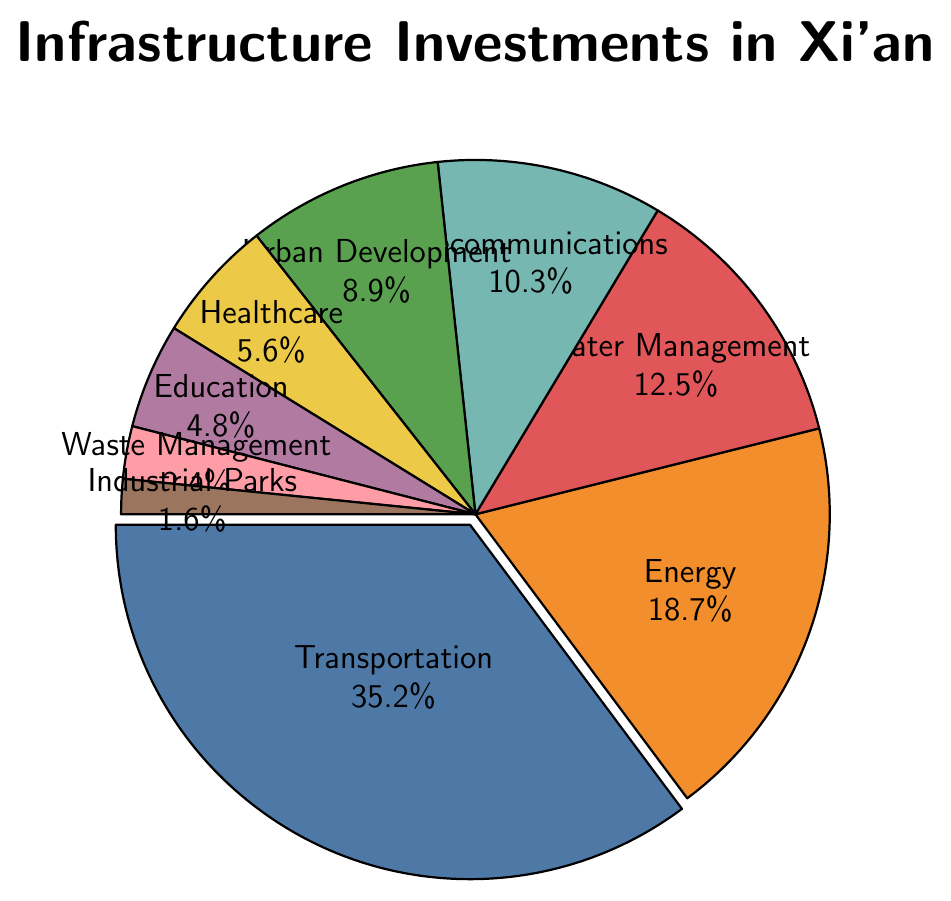Which sector has the highest investment percentage? The chart shows different sectors and their corresponding investment percentages. Among them, "Transportation" has the largest slice.
Answer: Transportation How much more is invested in Energy compared to Education Facilities? Energy investment is 18.7%, and Education Facilities is 4.8%. Subtract the two percentages to find the difference: 18.7% - 4.8% = 13.9%.
Answer: 13.9% What is the total percentage of investment in Urban Development, Healthcare Infrastructure, and Education Facilities combined? Sum the investment percentages for Urban Development (8.9%), Healthcare Infrastructure (5.6%), and Education Facilities (4.8%): 8.9% + 5.6% + 4.8% = 19.3%.
Answer: 19.3% Compare the investment in Telecommunications to Water Management. Which sector has a higher investment percentage and by how much? Telecommunications has an investment percentage of 10.3%, and Water Management has 12.5%. Subtract the percentage of Telecommunications from Water Management to find the difference: 12.5% - 10.3% = 2.2%.
Answer: Water Management has a higher investment by 2.2% What sectors have a combined investment percentage lower than that of Transportation? Transportation's investment percentage is 35.2%. Adding the investment percentages of Waste Management (2.4%) and Industrial Parks (1.6%) gives: 2.4% + 1.6% = 4.0%, which is lower than Transportation. Similarly, Healthcare Infrastructure (5.6%) and Education Facilities (4.8%) combined are: 5.6% + 4.8% = 10.4%, which is also lower. Urban Development (8.9%) alone is lower, as is Telecommunications (10.3%) and Water Management (12.5%).
Answer: Waste Management, Industrial Parks, Healthcare Infrastructure, Education Facilities, Urban Development, Telecommunications, and Water Management If you combine the investments in Energy and Telecommunications, do they exceed the investment in Transportation? Energy has an investment of 18.7%, and Telecommunications has 10.3%. Summing these gives: 18.7% + 10.3% = 29.0%, which is less than the Transportation investment of 35.2%.
Answer: No Which two sectors have the smallest investment percentages, and what is their combined percentage? The two smallest sectors are Industrial Parks (1.6%) and Waste Management (2.4%). Their combined percentage is: 1.6% + 2.4% = 4.0%.
Answer: Industrial Parks and Waste Management, 4.0% What percentage of the total investment is not allocated to Energy and Telecommunications? Energy investment is 18.7%, and Telecommunications is 10.3%. Total percentage allocated to these two sectors is: 18.7% + 10.3% = 29.0%. The remaining percentage is 100% - 29.0%= 71.0%.
Answer: 71.0% What color represents the Education Facilities sector in the chart? The chart is color-coded with distinct colors for each sector. Education Facilities is often represented by a lighter color and in this case, it is purple.
Answer: Purple 